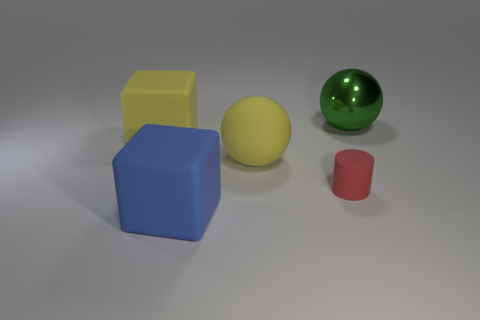Add 2 tiny red matte objects. How many objects exist? 7 Subtract all cylinders. How many objects are left? 4 Add 1 small rubber objects. How many small rubber objects are left? 2 Add 3 tiny red matte things. How many tiny red matte things exist? 4 Subtract 0 gray spheres. How many objects are left? 5 Subtract all tiny brown metal balls. Subtract all red matte things. How many objects are left? 4 